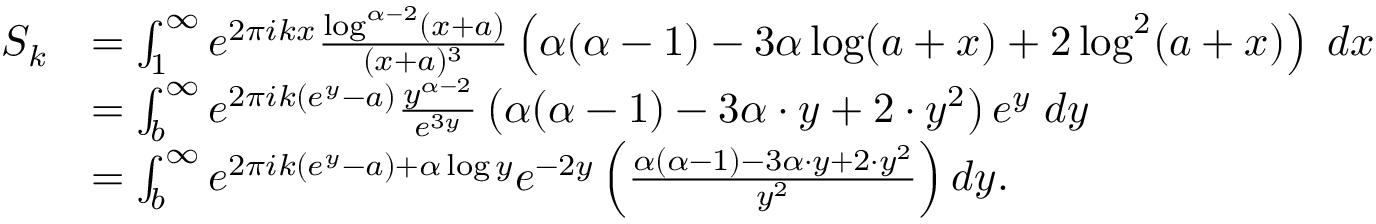Convert formula to latex. <formula><loc_0><loc_0><loc_500><loc_500>\begin{array} { r l } { S _ { k } } & { = \int _ { 1 } ^ { \infty } e ^ { 2 \pi i k x } \frac { \log ^ { \alpha - 2 } ( x + a ) } { ( x + a ) ^ { 3 } } \left ( \alpha ( \alpha - 1 ) - 3 \alpha \log ( a + x ) + 2 \log ^ { 2 } ( a + x ) \right ) \, d x } \\ & { = \int _ { b } ^ { \infty } e ^ { 2 \pi i k ( e ^ { y } - a ) } \frac { y ^ { \alpha - 2 } } { e ^ { 3 y } } \left ( \alpha ( \alpha - 1 ) - 3 \alpha \cdot y + 2 \cdot y ^ { 2 } \right ) e ^ { y } \, d y } \\ & { = \int _ { b } ^ { \infty } e ^ { 2 \pi i k ( e ^ { y } - a ) + \alpha \log y } e ^ { - 2 y } \left ( \frac { \alpha ( \alpha - 1 ) - 3 \alpha \cdot y + 2 \cdot y ^ { 2 } } { y ^ { 2 } } \right ) d y . } \end{array}</formula> 